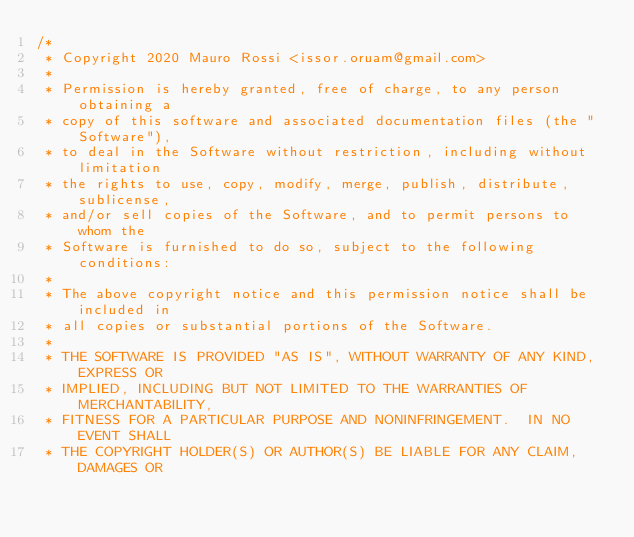Convert code to text. <code><loc_0><loc_0><loc_500><loc_500><_C_>/*
 * Copyright 2020 Mauro Rossi <issor.oruam@gmail.com>
 *
 * Permission is hereby granted, free of charge, to any person obtaining a
 * copy of this software and associated documentation files (the "Software"),
 * to deal in the Software without restriction, including without limitation
 * the rights to use, copy, modify, merge, publish, distribute, sublicense,
 * and/or sell copies of the Software, and to permit persons to whom the
 * Software is furnished to do so, subject to the following conditions:
 *
 * The above copyright notice and this permission notice shall be included in
 * all copies or substantial portions of the Software.
 *
 * THE SOFTWARE IS PROVIDED "AS IS", WITHOUT WARRANTY OF ANY KIND, EXPRESS OR
 * IMPLIED, INCLUDING BUT NOT LIMITED TO THE WARRANTIES OF MERCHANTABILITY,
 * FITNESS FOR A PARTICULAR PURPOSE AND NONINFRINGEMENT.  IN NO EVENT SHALL
 * THE COPYRIGHT HOLDER(S) OR AUTHOR(S) BE LIABLE FOR ANY CLAIM, DAMAGES OR</code> 